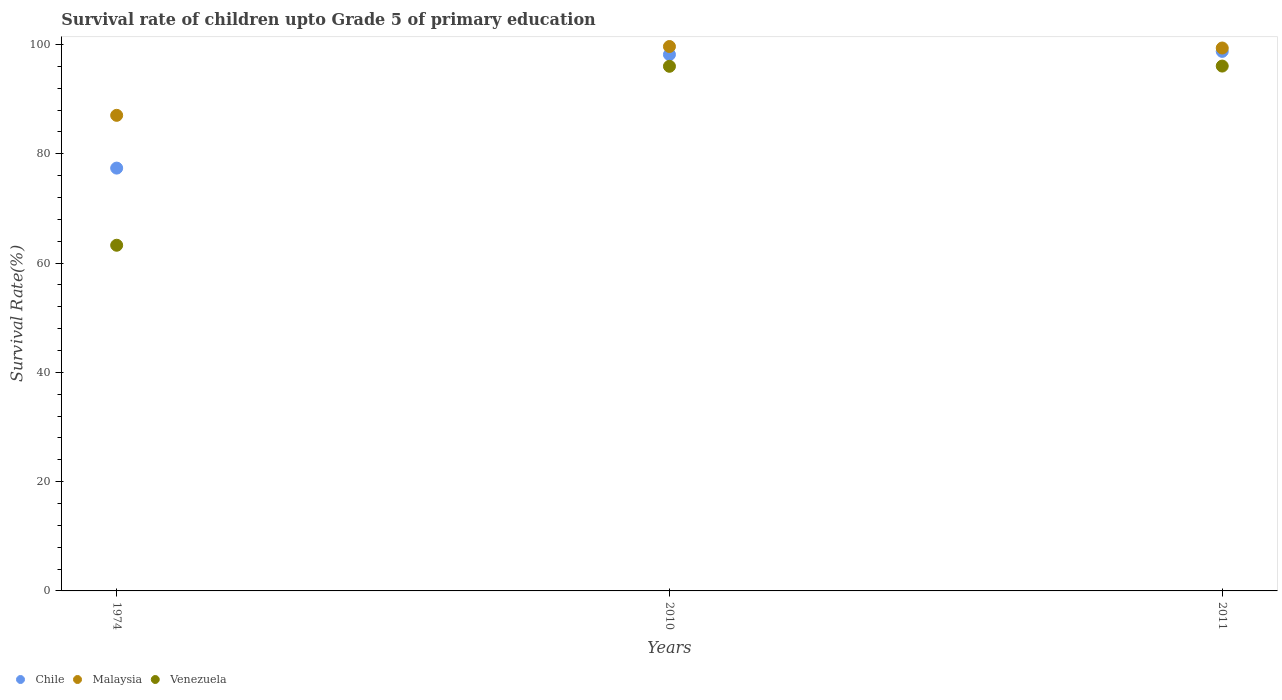How many different coloured dotlines are there?
Provide a succinct answer. 3. What is the survival rate of children in Malaysia in 2010?
Your answer should be very brief. 99.62. Across all years, what is the maximum survival rate of children in Malaysia?
Your answer should be compact. 99.62. Across all years, what is the minimum survival rate of children in Chile?
Offer a very short reply. 77.37. In which year was the survival rate of children in Malaysia maximum?
Provide a succinct answer. 2010. In which year was the survival rate of children in Malaysia minimum?
Offer a terse response. 1974. What is the total survival rate of children in Chile in the graph?
Offer a terse response. 274.24. What is the difference between the survival rate of children in Chile in 1974 and that in 2010?
Your answer should be very brief. -20.78. What is the difference between the survival rate of children in Malaysia in 2011 and the survival rate of children in Venezuela in 1974?
Make the answer very short. 36.09. What is the average survival rate of children in Venezuela per year?
Offer a very short reply. 85.1. In the year 1974, what is the difference between the survival rate of children in Malaysia and survival rate of children in Chile?
Keep it short and to the point. 9.66. In how many years, is the survival rate of children in Chile greater than 72 %?
Make the answer very short. 3. What is the ratio of the survival rate of children in Venezuela in 1974 to that in 2010?
Provide a succinct answer. 0.66. What is the difference between the highest and the second highest survival rate of children in Malaysia?
Keep it short and to the point. 0.27. What is the difference between the highest and the lowest survival rate of children in Chile?
Provide a succinct answer. 21.36. Is it the case that in every year, the sum of the survival rate of children in Malaysia and survival rate of children in Venezuela  is greater than the survival rate of children in Chile?
Make the answer very short. Yes. Does the survival rate of children in Malaysia monotonically increase over the years?
Your answer should be very brief. No. How many dotlines are there?
Offer a terse response. 3. Where does the legend appear in the graph?
Make the answer very short. Bottom left. How many legend labels are there?
Offer a very short reply. 3. What is the title of the graph?
Your answer should be compact. Survival rate of children upto Grade 5 of primary education. Does "Egypt, Arab Rep." appear as one of the legend labels in the graph?
Ensure brevity in your answer.  No. What is the label or title of the X-axis?
Offer a terse response. Years. What is the label or title of the Y-axis?
Offer a terse response. Survival Rate(%). What is the Survival Rate(%) of Chile in 1974?
Provide a succinct answer. 77.37. What is the Survival Rate(%) of Malaysia in 1974?
Provide a short and direct response. 87.03. What is the Survival Rate(%) in Venezuela in 1974?
Your answer should be very brief. 63.25. What is the Survival Rate(%) of Chile in 2010?
Provide a succinct answer. 98.15. What is the Survival Rate(%) in Malaysia in 2010?
Give a very brief answer. 99.62. What is the Survival Rate(%) of Venezuela in 2010?
Your answer should be very brief. 96. What is the Survival Rate(%) of Chile in 2011?
Offer a very short reply. 98.73. What is the Survival Rate(%) of Malaysia in 2011?
Your answer should be compact. 99.35. What is the Survival Rate(%) of Venezuela in 2011?
Keep it short and to the point. 96.04. Across all years, what is the maximum Survival Rate(%) of Chile?
Your response must be concise. 98.73. Across all years, what is the maximum Survival Rate(%) of Malaysia?
Provide a short and direct response. 99.62. Across all years, what is the maximum Survival Rate(%) of Venezuela?
Give a very brief answer. 96.04. Across all years, what is the minimum Survival Rate(%) in Chile?
Keep it short and to the point. 77.37. Across all years, what is the minimum Survival Rate(%) of Malaysia?
Your answer should be very brief. 87.03. Across all years, what is the minimum Survival Rate(%) of Venezuela?
Provide a succinct answer. 63.25. What is the total Survival Rate(%) in Chile in the graph?
Your answer should be very brief. 274.24. What is the total Survival Rate(%) of Malaysia in the graph?
Your answer should be very brief. 285.99. What is the total Survival Rate(%) of Venezuela in the graph?
Provide a short and direct response. 255.29. What is the difference between the Survival Rate(%) in Chile in 1974 and that in 2010?
Provide a short and direct response. -20.78. What is the difference between the Survival Rate(%) of Malaysia in 1974 and that in 2010?
Offer a very short reply. -12.59. What is the difference between the Survival Rate(%) of Venezuela in 1974 and that in 2010?
Provide a succinct answer. -32.74. What is the difference between the Survival Rate(%) in Chile in 1974 and that in 2011?
Provide a short and direct response. -21.36. What is the difference between the Survival Rate(%) in Malaysia in 1974 and that in 2011?
Ensure brevity in your answer.  -12.32. What is the difference between the Survival Rate(%) in Venezuela in 1974 and that in 2011?
Your answer should be very brief. -32.79. What is the difference between the Survival Rate(%) of Chile in 2010 and that in 2011?
Keep it short and to the point. -0.58. What is the difference between the Survival Rate(%) in Malaysia in 2010 and that in 2011?
Make the answer very short. 0.27. What is the difference between the Survival Rate(%) of Venezuela in 2010 and that in 2011?
Your answer should be very brief. -0.04. What is the difference between the Survival Rate(%) of Chile in 1974 and the Survival Rate(%) of Malaysia in 2010?
Provide a succinct answer. -22.25. What is the difference between the Survival Rate(%) in Chile in 1974 and the Survival Rate(%) in Venezuela in 2010?
Your response must be concise. -18.63. What is the difference between the Survival Rate(%) in Malaysia in 1974 and the Survival Rate(%) in Venezuela in 2010?
Ensure brevity in your answer.  -8.97. What is the difference between the Survival Rate(%) in Chile in 1974 and the Survival Rate(%) in Malaysia in 2011?
Offer a terse response. -21.98. What is the difference between the Survival Rate(%) of Chile in 1974 and the Survival Rate(%) of Venezuela in 2011?
Ensure brevity in your answer.  -18.67. What is the difference between the Survival Rate(%) in Malaysia in 1974 and the Survival Rate(%) in Venezuela in 2011?
Your answer should be compact. -9.01. What is the difference between the Survival Rate(%) in Chile in 2010 and the Survival Rate(%) in Malaysia in 2011?
Your response must be concise. -1.2. What is the difference between the Survival Rate(%) of Chile in 2010 and the Survival Rate(%) of Venezuela in 2011?
Provide a succinct answer. 2.1. What is the difference between the Survival Rate(%) of Malaysia in 2010 and the Survival Rate(%) of Venezuela in 2011?
Your answer should be compact. 3.58. What is the average Survival Rate(%) of Chile per year?
Offer a very short reply. 91.41. What is the average Survival Rate(%) in Malaysia per year?
Keep it short and to the point. 95.33. What is the average Survival Rate(%) of Venezuela per year?
Provide a short and direct response. 85.1. In the year 1974, what is the difference between the Survival Rate(%) of Chile and Survival Rate(%) of Malaysia?
Provide a succinct answer. -9.66. In the year 1974, what is the difference between the Survival Rate(%) in Chile and Survival Rate(%) in Venezuela?
Offer a very short reply. 14.12. In the year 1974, what is the difference between the Survival Rate(%) of Malaysia and Survival Rate(%) of Venezuela?
Ensure brevity in your answer.  23.77. In the year 2010, what is the difference between the Survival Rate(%) of Chile and Survival Rate(%) of Malaysia?
Provide a succinct answer. -1.47. In the year 2010, what is the difference between the Survival Rate(%) in Chile and Survival Rate(%) in Venezuela?
Provide a short and direct response. 2.15. In the year 2010, what is the difference between the Survival Rate(%) of Malaysia and Survival Rate(%) of Venezuela?
Ensure brevity in your answer.  3.62. In the year 2011, what is the difference between the Survival Rate(%) in Chile and Survival Rate(%) in Malaysia?
Your answer should be very brief. -0.62. In the year 2011, what is the difference between the Survival Rate(%) of Chile and Survival Rate(%) of Venezuela?
Keep it short and to the point. 2.69. In the year 2011, what is the difference between the Survival Rate(%) of Malaysia and Survival Rate(%) of Venezuela?
Your answer should be very brief. 3.3. What is the ratio of the Survival Rate(%) of Chile in 1974 to that in 2010?
Offer a very short reply. 0.79. What is the ratio of the Survival Rate(%) in Malaysia in 1974 to that in 2010?
Provide a short and direct response. 0.87. What is the ratio of the Survival Rate(%) of Venezuela in 1974 to that in 2010?
Give a very brief answer. 0.66. What is the ratio of the Survival Rate(%) of Chile in 1974 to that in 2011?
Your answer should be very brief. 0.78. What is the ratio of the Survival Rate(%) in Malaysia in 1974 to that in 2011?
Your answer should be very brief. 0.88. What is the ratio of the Survival Rate(%) in Venezuela in 1974 to that in 2011?
Offer a very short reply. 0.66. What is the ratio of the Survival Rate(%) in Chile in 2010 to that in 2011?
Make the answer very short. 0.99. What is the ratio of the Survival Rate(%) of Malaysia in 2010 to that in 2011?
Ensure brevity in your answer.  1. What is the ratio of the Survival Rate(%) of Venezuela in 2010 to that in 2011?
Make the answer very short. 1. What is the difference between the highest and the second highest Survival Rate(%) in Chile?
Your answer should be compact. 0.58. What is the difference between the highest and the second highest Survival Rate(%) of Malaysia?
Keep it short and to the point. 0.27. What is the difference between the highest and the second highest Survival Rate(%) of Venezuela?
Ensure brevity in your answer.  0.04. What is the difference between the highest and the lowest Survival Rate(%) in Chile?
Provide a succinct answer. 21.36. What is the difference between the highest and the lowest Survival Rate(%) of Malaysia?
Ensure brevity in your answer.  12.59. What is the difference between the highest and the lowest Survival Rate(%) of Venezuela?
Provide a succinct answer. 32.79. 